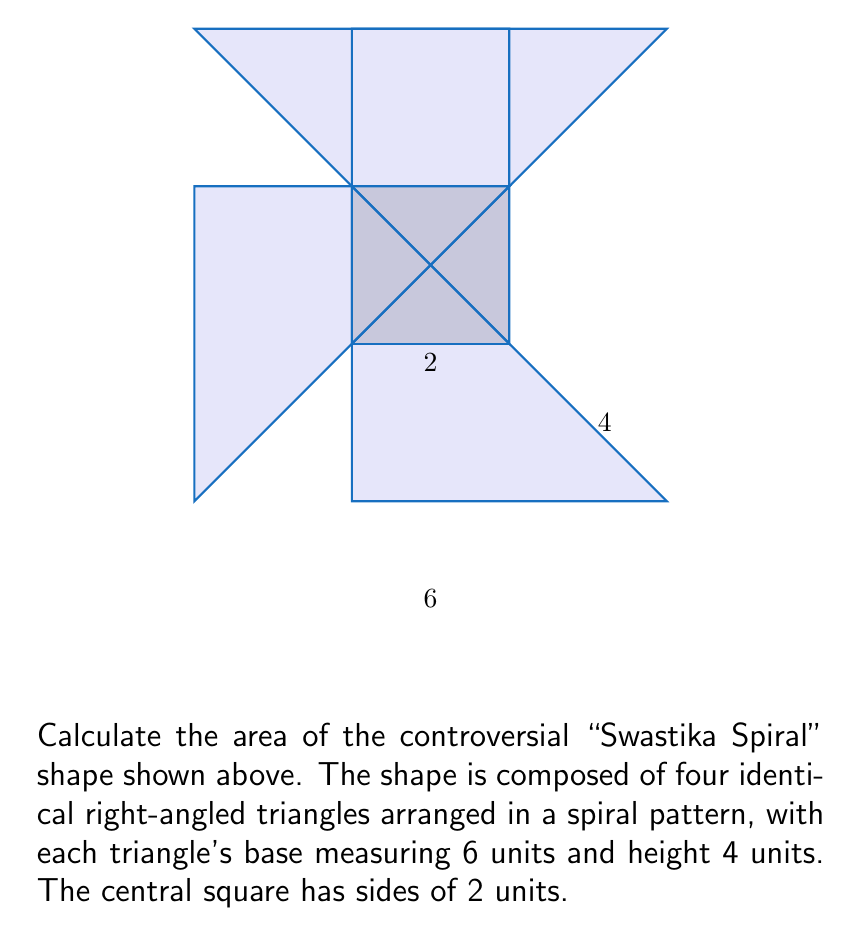Solve this math problem. To calculate the area of the "Swastika Spiral" shape, we'll break it down into its components:

1) Area of each triangle:
   $$A_t = \frac{1}{2} \times base \times height = \frac{1}{2} \times 6 \times 4 = 12$$ square units

2) There are four identical triangles, so the total area of triangles is:
   $$A_{total\_t} = 4 \times 12 = 48$$ square units

3) Area of the central square:
   $$A_s = side^2 = 2^2 = 4$$ square units

4) Total area of the shape:
   $$A_{total} = A_{total\_t} + A_s = 48 + 4 = 52$$ square units

Therefore, the total area of the "Swastika Spiral" shape is 52 square units.
Answer: 52 square units 